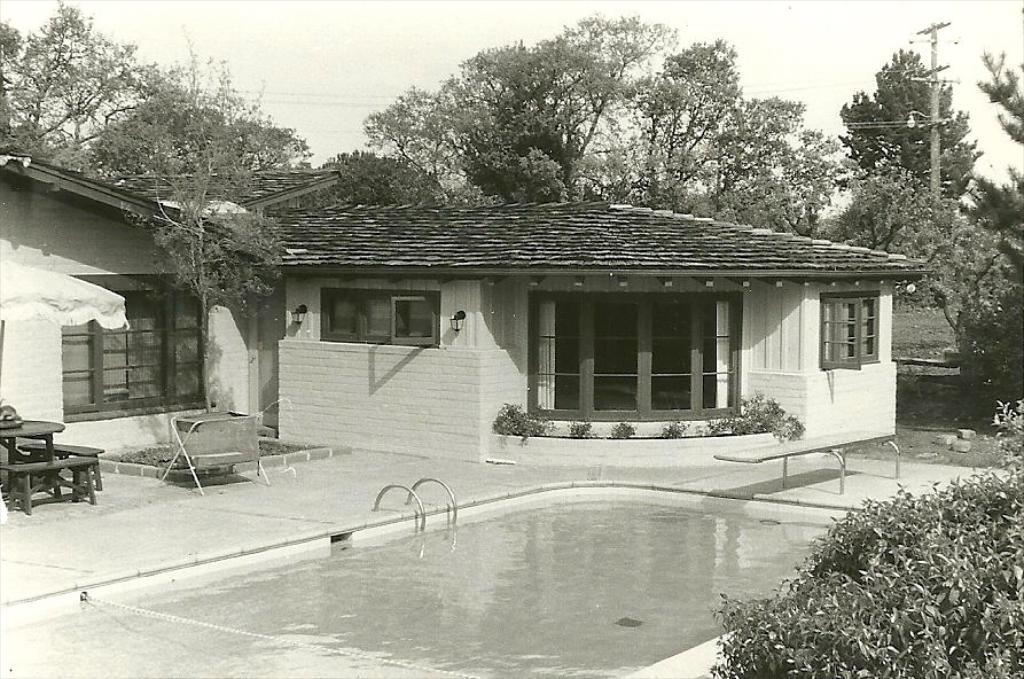Describe this image in one or two sentences. In this image there is a house. In front of the house there are tables and chairs. At the bottom there is a swimming pool. In the bottom right there are plants. Behind the house there are trees and poles. At the top there is the sky. 